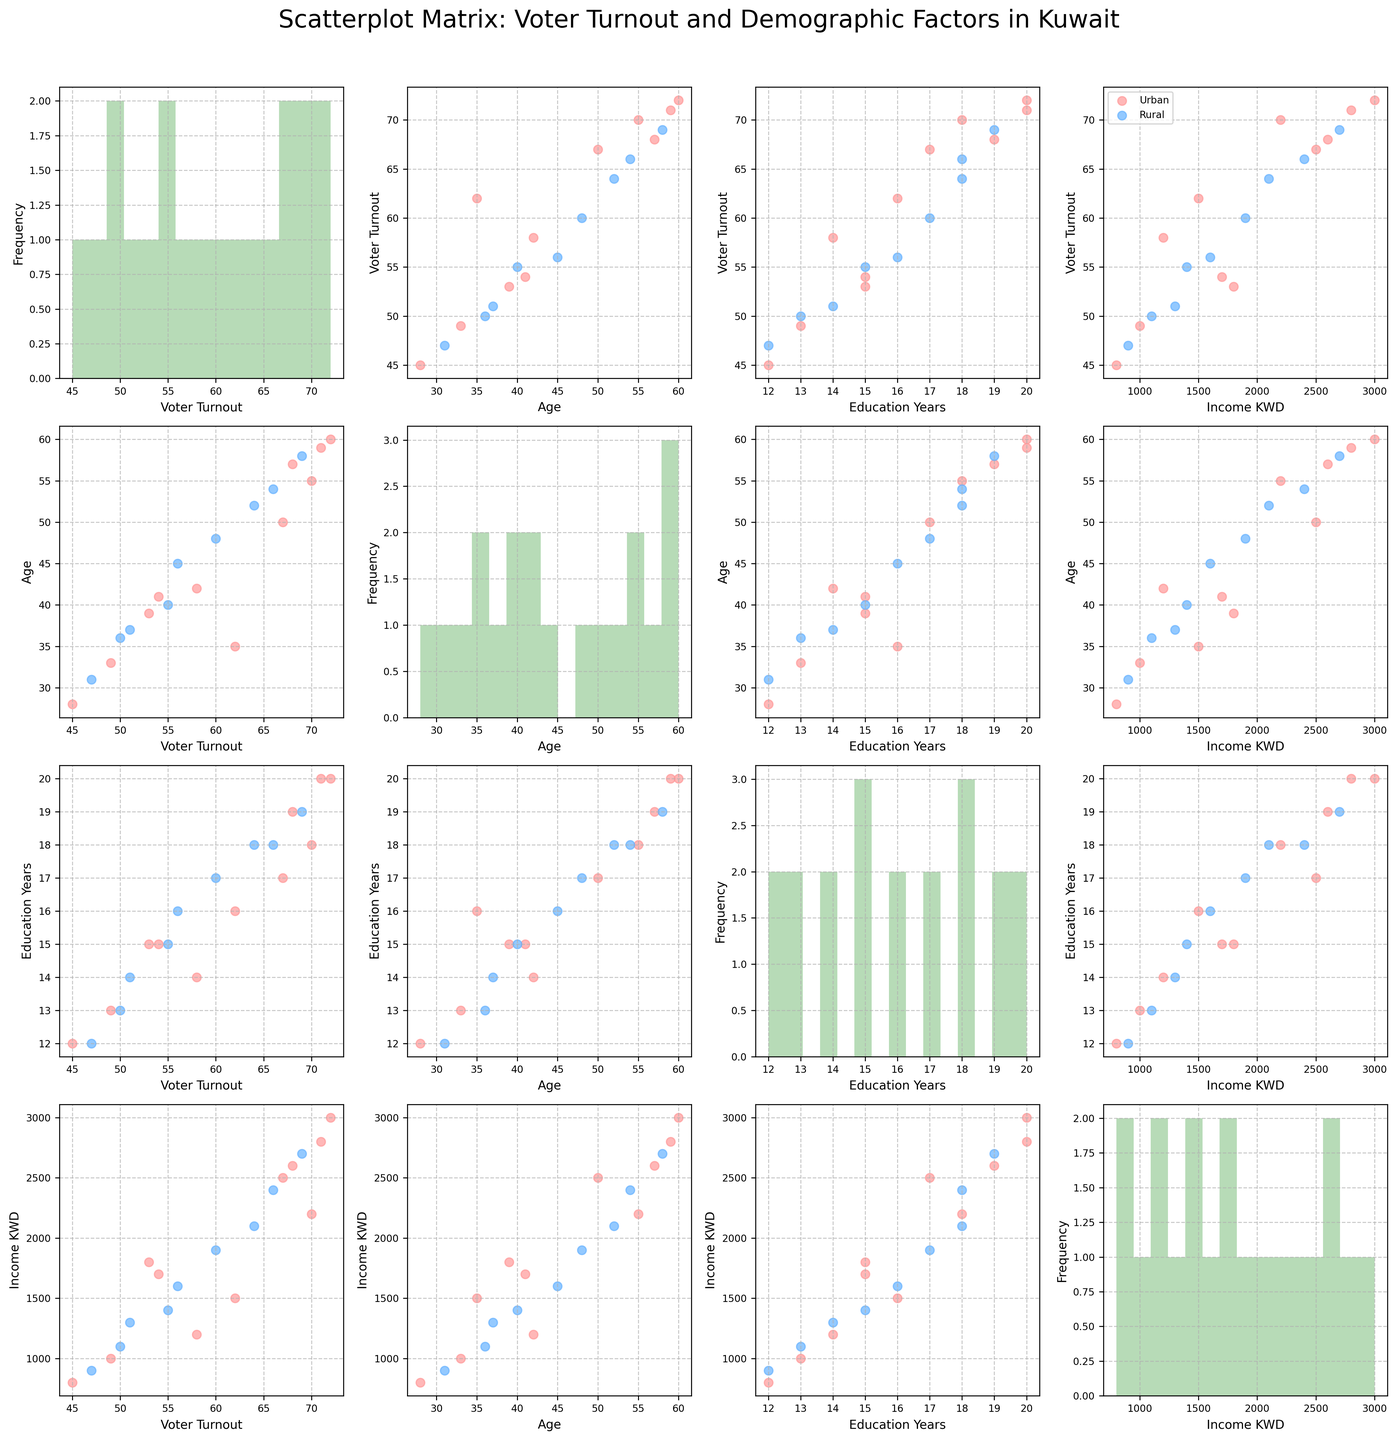What are the primary demographic factors being analyzed in the scatterplot matrix? The scatterplot matrix includes the following demographic factors on its axes: Voter Turnout, Age, Education Years, and Income (KWD). These factors are plotted against one another to analyze their relationships.
Answer: Voter Turnout, Age, Education Years, Income (KWD) Is there a difference in Voter Turnout between urban and rural areas? The scatterplot shows data points for urban represented in a red hue and rural in a blue hue. By comparing these points in the Voter Turnout axis across the scatterplots, one can visually assess if there is a noticeable difference between turnout rates for urban and rural areas.
Answer: Yes, there is a visible difference How does Voter Turnout correlate with Age for urban residents? By observing the scatterplot of Voter Turnout (y-axis) versus Age (x-axis) for the urban residents (marked with a red hue), one can deduce if there’s a positive, negative, or no correlation based on the trend of the red-marked points.
Answer: There is a positive correlation Which demographic factor appears to have the strongest correlation with Voter Turnout? By scanning through the scatterplot matrix and visually noting which demographic factor (Age, Education Years, Income KWD) has the most linear trend with Voter Turnout (regardless of urban or rural), one can identify the strongest correlation.
Answer: Education Years How does the distribution of Age differ between urban and rural groups? By looking at the Age histograms (diagonal plots) for the urban (red) and rural (blue) groups, one can compare the spread and peaks of ages in both groups to draw insights about their distributions.
Answer: Urban distribution is centered on older ages, while rural is more spread out Can we see a trend between Education Years and Income across the scatterplots? Observing the scatterplot with Education Years on the x-axis and Income on the y-axis, one can look for any visible trends or patterns among the data points, such as a linear increase in income with more education years.
Answer: Yes, there is an increasing trend Is there a noticeable difference in Income levels between urban and rural groups? In the scatterplots where Income is one of the axes, comparing the red points (urban) with the blue points (rural) can reveal differences in income levels between these demographic groups.
Answer: Yes, urban income levels are generally higher Which group, urban or rural, has the highest Voter Turnout among the provided data points? By examining the Voter Turnout axis, one can identify the highest data points and check their corresponding color representation to see if they belong to urban (red) or rural (blue) groups.
Answer: Urban What is the range of Education Years for the data points? This can be observed from the histogram of Education Years on the diagonal, showing the spread and range of the Education Years from the minimum to the maximum bin.
Answer: 12 to 20 years 